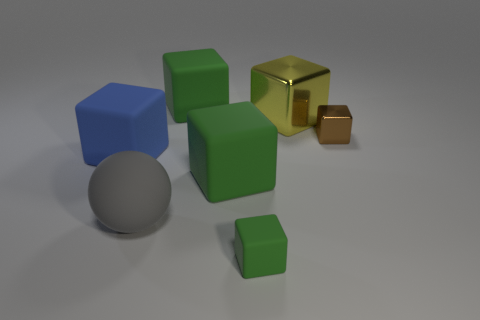Subtract all yellow spheres. How many green cubes are left? 3 Subtract all blue cubes. How many cubes are left? 5 Subtract all tiny green rubber cubes. How many cubes are left? 5 Subtract all yellow blocks. Subtract all gray spheres. How many blocks are left? 5 Add 2 big blue matte objects. How many objects exist? 9 Subtract all spheres. How many objects are left? 6 Subtract 0 cyan spheres. How many objects are left? 7 Subtract all blue cylinders. Subtract all big gray objects. How many objects are left? 6 Add 3 small green rubber things. How many small green rubber things are left? 4 Add 3 tiny red shiny things. How many tiny red shiny things exist? 3 